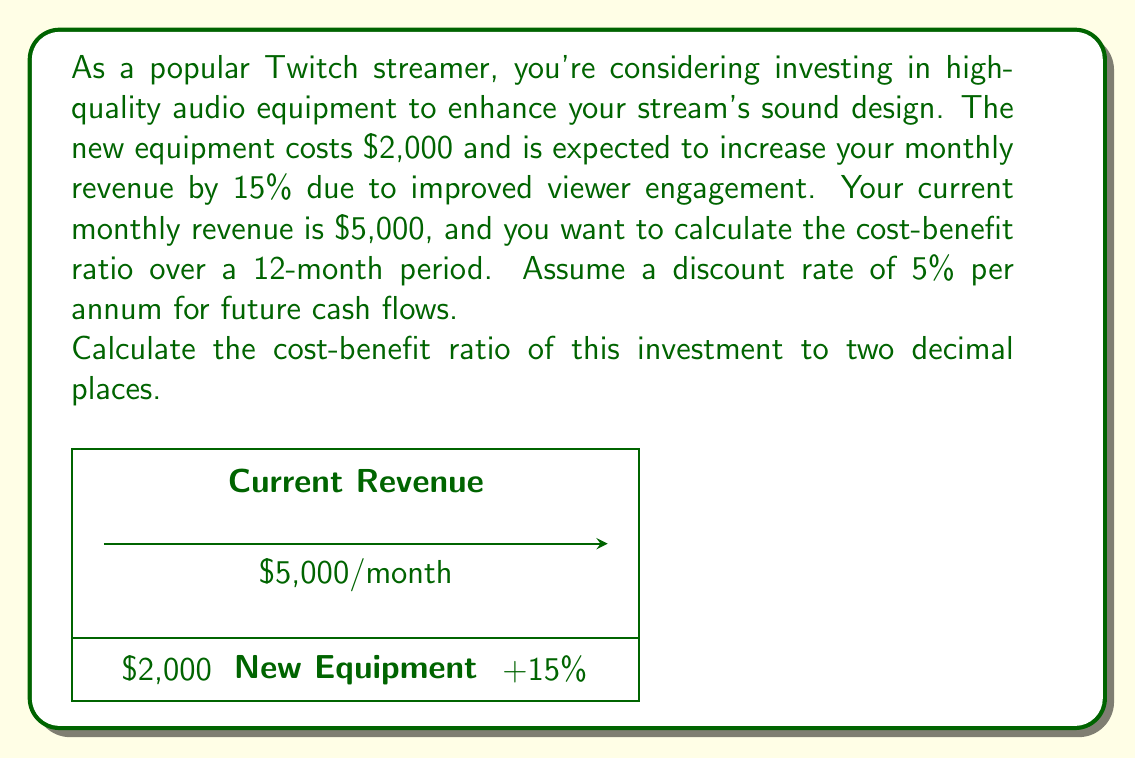Show me your answer to this math problem. To calculate the cost-benefit ratio, we need to follow these steps:

1. Calculate the increased monthly revenue:
   $5,000 \times 15\% = $750$ additional revenue per month

2. Calculate the total benefit over 12 months:
   We need to discount future cash flows using the given annual discount rate of 5%.
   Monthly discount rate = $5\% / 12 = 0.4167\%$ per month
   
   Present Value of benefits = $\sum_{t=1}^{12} \frac{750}{(1 + 0.004167)^t}$
   
   Using the present value of an annuity formula:
   $PV = A \times \frac{1 - (1+r)^{-n}}{r}$
   Where $A = 750$, $r = 0.004167$, and $n = 12$
   
   $PV = 750 \times \frac{1 - (1+0.004167)^{-12}}{0.004167} = $8,847.76$

3. Calculate the cost-benefit ratio:
   Cost-Benefit Ratio = $\frac{\text{Present Value of Benefits}}{\text{Cost}}$
   
   $\text{Cost-Benefit Ratio} = \frac{8,847.76}{2,000} = 4.42$

Therefore, the cost-benefit ratio of investing in the high-quality audio equipment is 4.42 to 1.
Answer: 4.42 